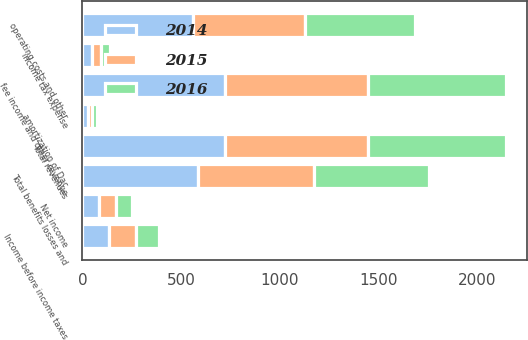Convert chart. <chart><loc_0><loc_0><loc_500><loc_500><stacked_bar_chart><ecel><fcel>fee income and other revenue<fcel>Total revenues<fcel>amortization of Dac<fcel>operating costs and other<fcel>Total benefits losses and<fcel>Income before income taxes<fcel>income tax expense<fcel>Net income<nl><fcel>2016<fcel>701<fcel>702<fcel>24<fcel>557<fcel>581<fcel>121<fcel>43<fcel>78<nl><fcel>2015<fcel>723<fcel>724<fcel>22<fcel>568<fcel>590<fcel>134<fcel>48<fcel>86<nl><fcel>2014<fcel>723<fcel>723<fcel>28<fcel>559<fcel>587<fcel>136<fcel>49<fcel>87<nl></chart> 